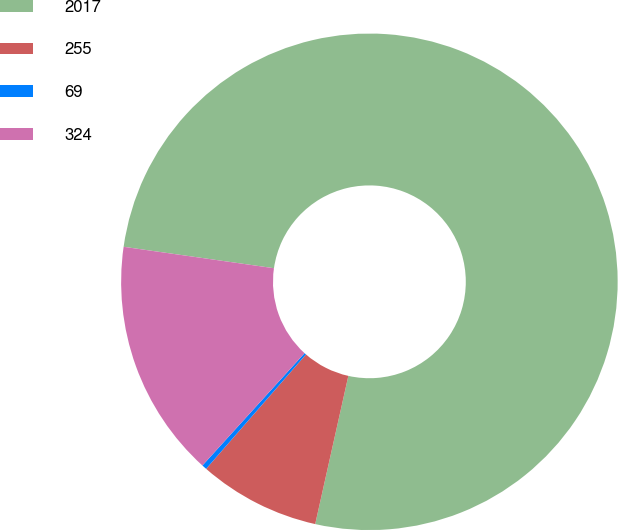Convert chart. <chart><loc_0><loc_0><loc_500><loc_500><pie_chart><fcel>2017<fcel>255<fcel>69<fcel>324<nl><fcel>76.25%<fcel>7.92%<fcel>0.32%<fcel>15.51%<nl></chart> 